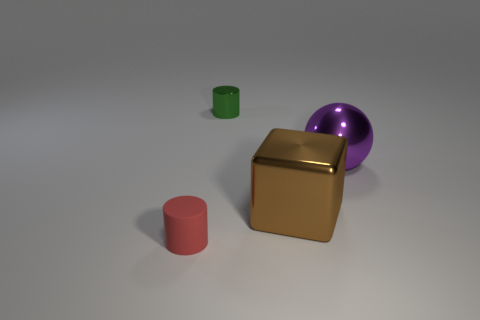What number of cylinders are purple metal objects or purple matte things?
Offer a terse response. 0. Does the large purple shiny object have the same shape as the tiny object that is behind the matte thing?
Ensure brevity in your answer.  No. There is a object that is both on the left side of the brown metal block and in front of the large purple shiny ball; how big is it?
Your answer should be very brief. Small. There is a big purple shiny object; what shape is it?
Offer a terse response. Sphere. Is there a tiny object behind the small thing that is on the left side of the green shiny cylinder?
Provide a succinct answer. Yes. There is a cylinder right of the red thing; how many rubber objects are in front of it?
Provide a short and direct response. 1. There is another cylinder that is the same size as the matte cylinder; what is it made of?
Keep it short and to the point. Metal. There is a object right of the brown metal object; does it have the same shape as the red object?
Provide a succinct answer. No. Are there more small cylinders that are in front of the tiny red rubber object than red cylinders that are behind the green object?
Your answer should be compact. No. How many brown cubes have the same material as the green object?
Offer a terse response. 1. 